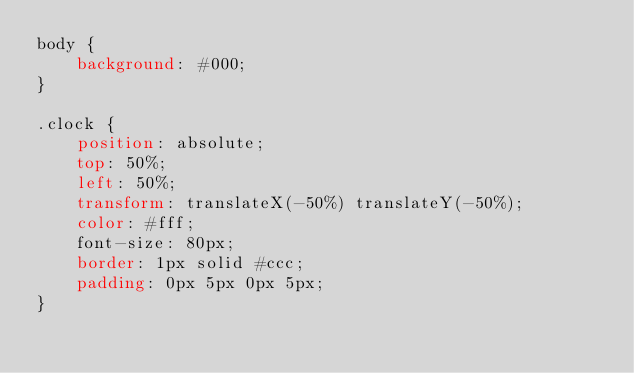<code> <loc_0><loc_0><loc_500><loc_500><_CSS_>body {
    background: #000;
}

.clock {
    position: absolute;
    top: 50%;
    left: 50%;
    transform: translateX(-50%) translateY(-50%);
    color: #fff;
    font-size: 80px;
    border: 1px solid #ccc;
    padding: 0px 5px 0px 5px;
}</code> 